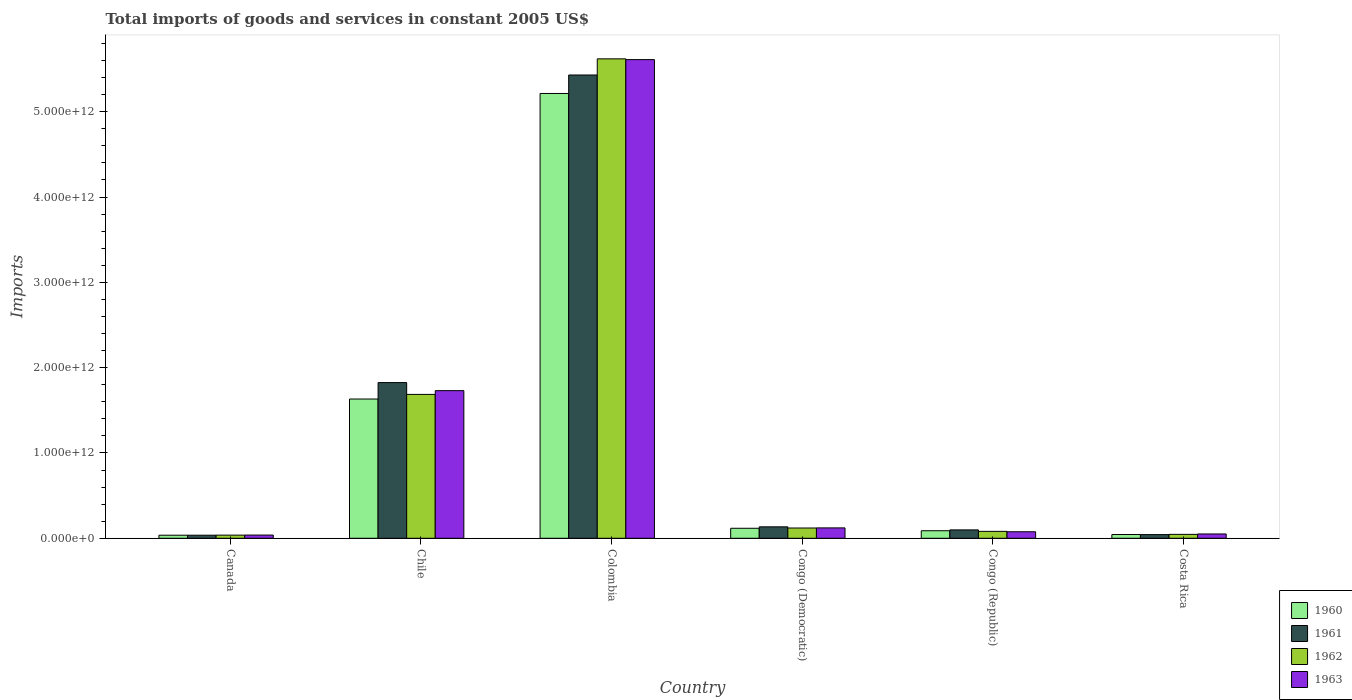Are the number of bars per tick equal to the number of legend labels?
Keep it short and to the point. Yes. How many bars are there on the 5th tick from the right?
Ensure brevity in your answer.  4. What is the label of the 4th group of bars from the left?
Your response must be concise. Congo (Democratic). In how many cases, is the number of bars for a given country not equal to the number of legend labels?
Your answer should be compact. 0. What is the total imports of goods and services in 1960 in Congo (Democratic)?
Provide a short and direct response. 1.17e+11. Across all countries, what is the maximum total imports of goods and services in 1963?
Provide a short and direct response. 5.61e+12. Across all countries, what is the minimum total imports of goods and services in 1960?
Make the answer very short. 3.60e+1. In which country was the total imports of goods and services in 1963 minimum?
Provide a short and direct response. Canada. What is the total total imports of goods and services in 1960 in the graph?
Make the answer very short. 7.13e+12. What is the difference between the total imports of goods and services in 1963 in Canada and that in Chile?
Your answer should be compact. -1.69e+12. What is the difference between the total imports of goods and services in 1960 in Chile and the total imports of goods and services in 1963 in Costa Rica?
Ensure brevity in your answer.  1.58e+12. What is the average total imports of goods and services in 1961 per country?
Offer a very short reply. 1.26e+12. What is the difference between the total imports of goods and services of/in 1963 and total imports of goods and services of/in 1961 in Costa Rica?
Your response must be concise. 7.69e+09. What is the ratio of the total imports of goods and services in 1963 in Colombia to that in Congo (Republic)?
Your response must be concise. 73.33. What is the difference between the highest and the second highest total imports of goods and services in 1961?
Your answer should be compact. -3.61e+12. What is the difference between the highest and the lowest total imports of goods and services in 1962?
Keep it short and to the point. 5.58e+12. Is the sum of the total imports of goods and services in 1963 in Canada and Costa Rica greater than the maximum total imports of goods and services in 1961 across all countries?
Make the answer very short. No. Is it the case that in every country, the sum of the total imports of goods and services in 1960 and total imports of goods and services in 1962 is greater than the sum of total imports of goods and services in 1961 and total imports of goods and services in 1963?
Offer a terse response. No. What does the 1st bar from the right in Colombia represents?
Your answer should be very brief. 1963. Is it the case that in every country, the sum of the total imports of goods and services in 1963 and total imports of goods and services in 1961 is greater than the total imports of goods and services in 1962?
Give a very brief answer. Yes. Are all the bars in the graph horizontal?
Your response must be concise. No. What is the difference between two consecutive major ticks on the Y-axis?
Your answer should be very brief. 1.00e+12. Are the values on the major ticks of Y-axis written in scientific E-notation?
Provide a short and direct response. Yes. Does the graph contain any zero values?
Provide a short and direct response. No. Where does the legend appear in the graph?
Give a very brief answer. Bottom right. What is the title of the graph?
Ensure brevity in your answer.  Total imports of goods and services in constant 2005 US$. Does "2007" appear as one of the legend labels in the graph?
Your response must be concise. No. What is the label or title of the Y-axis?
Your response must be concise. Imports. What is the Imports of 1960 in Canada?
Provide a succinct answer. 3.60e+1. What is the Imports in 1961 in Canada?
Offer a terse response. 3.61e+1. What is the Imports in 1962 in Canada?
Give a very brief answer. 3.69e+1. What is the Imports of 1963 in Canada?
Your response must be concise. 3.79e+1. What is the Imports in 1960 in Chile?
Make the answer very short. 1.63e+12. What is the Imports in 1961 in Chile?
Your answer should be very brief. 1.82e+12. What is the Imports of 1962 in Chile?
Your response must be concise. 1.69e+12. What is the Imports of 1963 in Chile?
Offer a terse response. 1.73e+12. What is the Imports of 1960 in Colombia?
Your answer should be compact. 5.21e+12. What is the Imports of 1961 in Colombia?
Give a very brief answer. 5.43e+12. What is the Imports in 1962 in Colombia?
Your answer should be very brief. 5.62e+12. What is the Imports in 1963 in Colombia?
Offer a very short reply. 5.61e+12. What is the Imports of 1960 in Congo (Democratic)?
Give a very brief answer. 1.17e+11. What is the Imports of 1961 in Congo (Democratic)?
Ensure brevity in your answer.  1.34e+11. What is the Imports of 1962 in Congo (Democratic)?
Your response must be concise. 1.20e+11. What is the Imports in 1963 in Congo (Democratic)?
Ensure brevity in your answer.  1.22e+11. What is the Imports of 1960 in Congo (Republic)?
Your answer should be compact. 8.83e+1. What is the Imports in 1961 in Congo (Republic)?
Ensure brevity in your answer.  9.83e+1. What is the Imports in 1962 in Congo (Republic)?
Your response must be concise. 8.10e+1. What is the Imports in 1963 in Congo (Republic)?
Ensure brevity in your answer.  7.65e+1. What is the Imports of 1960 in Costa Rica?
Ensure brevity in your answer.  4.40e+1. What is the Imports of 1961 in Costa Rica?
Your response must be concise. 4.30e+1. What is the Imports of 1962 in Costa Rica?
Your answer should be compact. 4.58e+1. What is the Imports of 1963 in Costa Rica?
Your response must be concise. 5.07e+1. Across all countries, what is the maximum Imports in 1960?
Your response must be concise. 5.21e+12. Across all countries, what is the maximum Imports of 1961?
Make the answer very short. 5.43e+12. Across all countries, what is the maximum Imports of 1962?
Offer a very short reply. 5.62e+12. Across all countries, what is the maximum Imports of 1963?
Your response must be concise. 5.61e+12. Across all countries, what is the minimum Imports in 1960?
Keep it short and to the point. 3.60e+1. Across all countries, what is the minimum Imports of 1961?
Your response must be concise. 3.61e+1. Across all countries, what is the minimum Imports in 1962?
Your response must be concise. 3.69e+1. Across all countries, what is the minimum Imports in 1963?
Offer a terse response. 3.79e+1. What is the total Imports in 1960 in the graph?
Your answer should be very brief. 7.13e+12. What is the total Imports of 1961 in the graph?
Provide a succinct answer. 7.57e+12. What is the total Imports in 1962 in the graph?
Ensure brevity in your answer.  7.59e+12. What is the total Imports of 1963 in the graph?
Provide a succinct answer. 7.63e+12. What is the difference between the Imports in 1960 in Canada and that in Chile?
Keep it short and to the point. -1.60e+12. What is the difference between the Imports of 1961 in Canada and that in Chile?
Your answer should be very brief. -1.79e+12. What is the difference between the Imports in 1962 in Canada and that in Chile?
Ensure brevity in your answer.  -1.65e+12. What is the difference between the Imports in 1963 in Canada and that in Chile?
Offer a very short reply. -1.69e+12. What is the difference between the Imports of 1960 in Canada and that in Colombia?
Provide a short and direct response. -5.18e+12. What is the difference between the Imports in 1961 in Canada and that in Colombia?
Your answer should be compact. -5.39e+12. What is the difference between the Imports of 1962 in Canada and that in Colombia?
Your response must be concise. -5.58e+12. What is the difference between the Imports of 1963 in Canada and that in Colombia?
Ensure brevity in your answer.  -5.57e+12. What is the difference between the Imports in 1960 in Canada and that in Congo (Democratic)?
Give a very brief answer. -8.14e+1. What is the difference between the Imports of 1961 in Canada and that in Congo (Democratic)?
Your response must be concise. -9.81e+1. What is the difference between the Imports in 1962 in Canada and that in Congo (Democratic)?
Provide a short and direct response. -8.36e+1. What is the difference between the Imports of 1963 in Canada and that in Congo (Democratic)?
Provide a succinct answer. -8.39e+1. What is the difference between the Imports of 1960 in Canada and that in Congo (Republic)?
Your answer should be very brief. -5.24e+1. What is the difference between the Imports of 1961 in Canada and that in Congo (Republic)?
Make the answer very short. -6.22e+1. What is the difference between the Imports of 1962 in Canada and that in Congo (Republic)?
Your answer should be compact. -4.41e+1. What is the difference between the Imports in 1963 in Canada and that in Congo (Republic)?
Your answer should be compact. -3.86e+1. What is the difference between the Imports in 1960 in Canada and that in Costa Rica?
Offer a very short reply. -8.03e+09. What is the difference between the Imports in 1961 in Canada and that in Costa Rica?
Your answer should be very brief. -6.97e+09. What is the difference between the Imports of 1962 in Canada and that in Costa Rica?
Keep it short and to the point. -8.88e+09. What is the difference between the Imports in 1963 in Canada and that in Costa Rica?
Your answer should be compact. -1.28e+1. What is the difference between the Imports in 1960 in Chile and that in Colombia?
Provide a short and direct response. -3.58e+12. What is the difference between the Imports in 1961 in Chile and that in Colombia?
Your answer should be compact. -3.61e+12. What is the difference between the Imports of 1962 in Chile and that in Colombia?
Your response must be concise. -3.93e+12. What is the difference between the Imports of 1963 in Chile and that in Colombia?
Keep it short and to the point. -3.88e+12. What is the difference between the Imports in 1960 in Chile and that in Congo (Democratic)?
Give a very brief answer. 1.51e+12. What is the difference between the Imports of 1961 in Chile and that in Congo (Democratic)?
Provide a succinct answer. 1.69e+12. What is the difference between the Imports in 1962 in Chile and that in Congo (Democratic)?
Ensure brevity in your answer.  1.57e+12. What is the difference between the Imports in 1963 in Chile and that in Congo (Democratic)?
Ensure brevity in your answer.  1.61e+12. What is the difference between the Imports in 1960 in Chile and that in Congo (Republic)?
Your answer should be compact. 1.54e+12. What is the difference between the Imports in 1961 in Chile and that in Congo (Republic)?
Provide a short and direct response. 1.73e+12. What is the difference between the Imports of 1962 in Chile and that in Congo (Republic)?
Offer a terse response. 1.61e+12. What is the difference between the Imports in 1963 in Chile and that in Congo (Republic)?
Make the answer very short. 1.65e+12. What is the difference between the Imports in 1960 in Chile and that in Costa Rica?
Provide a short and direct response. 1.59e+12. What is the difference between the Imports of 1961 in Chile and that in Costa Rica?
Your answer should be very brief. 1.78e+12. What is the difference between the Imports of 1962 in Chile and that in Costa Rica?
Offer a very short reply. 1.64e+12. What is the difference between the Imports of 1963 in Chile and that in Costa Rica?
Ensure brevity in your answer.  1.68e+12. What is the difference between the Imports of 1960 in Colombia and that in Congo (Democratic)?
Provide a short and direct response. 5.10e+12. What is the difference between the Imports in 1961 in Colombia and that in Congo (Democratic)?
Provide a short and direct response. 5.30e+12. What is the difference between the Imports in 1962 in Colombia and that in Congo (Democratic)?
Provide a succinct answer. 5.50e+12. What is the difference between the Imports of 1963 in Colombia and that in Congo (Democratic)?
Provide a succinct answer. 5.49e+12. What is the difference between the Imports in 1960 in Colombia and that in Congo (Republic)?
Offer a terse response. 5.13e+12. What is the difference between the Imports of 1961 in Colombia and that in Congo (Republic)?
Provide a succinct answer. 5.33e+12. What is the difference between the Imports in 1962 in Colombia and that in Congo (Republic)?
Offer a terse response. 5.54e+12. What is the difference between the Imports of 1963 in Colombia and that in Congo (Republic)?
Give a very brief answer. 5.53e+12. What is the difference between the Imports of 1960 in Colombia and that in Costa Rica?
Give a very brief answer. 5.17e+12. What is the difference between the Imports of 1961 in Colombia and that in Costa Rica?
Ensure brevity in your answer.  5.39e+12. What is the difference between the Imports in 1962 in Colombia and that in Costa Rica?
Provide a succinct answer. 5.57e+12. What is the difference between the Imports of 1963 in Colombia and that in Costa Rica?
Give a very brief answer. 5.56e+12. What is the difference between the Imports of 1960 in Congo (Democratic) and that in Congo (Republic)?
Give a very brief answer. 2.90e+1. What is the difference between the Imports in 1961 in Congo (Democratic) and that in Congo (Republic)?
Offer a terse response. 3.59e+1. What is the difference between the Imports in 1962 in Congo (Democratic) and that in Congo (Republic)?
Provide a short and direct response. 3.95e+1. What is the difference between the Imports in 1963 in Congo (Democratic) and that in Congo (Republic)?
Your answer should be very brief. 4.53e+1. What is the difference between the Imports of 1960 in Congo (Democratic) and that in Costa Rica?
Your response must be concise. 7.34e+1. What is the difference between the Imports in 1961 in Congo (Democratic) and that in Costa Rica?
Provide a succinct answer. 9.11e+1. What is the difference between the Imports in 1962 in Congo (Democratic) and that in Costa Rica?
Your response must be concise. 7.47e+1. What is the difference between the Imports of 1963 in Congo (Democratic) and that in Costa Rica?
Provide a short and direct response. 7.11e+1. What is the difference between the Imports in 1960 in Congo (Republic) and that in Costa Rica?
Provide a succinct answer. 4.43e+1. What is the difference between the Imports of 1961 in Congo (Republic) and that in Costa Rica?
Your answer should be compact. 5.52e+1. What is the difference between the Imports of 1962 in Congo (Republic) and that in Costa Rica?
Keep it short and to the point. 3.52e+1. What is the difference between the Imports of 1963 in Congo (Republic) and that in Costa Rica?
Keep it short and to the point. 2.58e+1. What is the difference between the Imports in 1960 in Canada and the Imports in 1961 in Chile?
Offer a very short reply. -1.79e+12. What is the difference between the Imports in 1960 in Canada and the Imports in 1962 in Chile?
Offer a very short reply. -1.65e+12. What is the difference between the Imports of 1960 in Canada and the Imports of 1963 in Chile?
Your answer should be compact. -1.69e+12. What is the difference between the Imports in 1961 in Canada and the Imports in 1962 in Chile?
Provide a short and direct response. -1.65e+12. What is the difference between the Imports in 1961 in Canada and the Imports in 1963 in Chile?
Ensure brevity in your answer.  -1.69e+12. What is the difference between the Imports in 1962 in Canada and the Imports in 1963 in Chile?
Your response must be concise. -1.69e+12. What is the difference between the Imports in 1960 in Canada and the Imports in 1961 in Colombia?
Ensure brevity in your answer.  -5.39e+12. What is the difference between the Imports in 1960 in Canada and the Imports in 1962 in Colombia?
Provide a short and direct response. -5.58e+12. What is the difference between the Imports of 1960 in Canada and the Imports of 1963 in Colombia?
Provide a succinct answer. -5.57e+12. What is the difference between the Imports of 1961 in Canada and the Imports of 1962 in Colombia?
Make the answer very short. -5.58e+12. What is the difference between the Imports of 1961 in Canada and the Imports of 1963 in Colombia?
Ensure brevity in your answer.  -5.57e+12. What is the difference between the Imports of 1962 in Canada and the Imports of 1963 in Colombia?
Ensure brevity in your answer.  -5.57e+12. What is the difference between the Imports of 1960 in Canada and the Imports of 1961 in Congo (Democratic)?
Your answer should be very brief. -9.82e+1. What is the difference between the Imports in 1960 in Canada and the Imports in 1962 in Congo (Democratic)?
Your answer should be compact. -8.45e+1. What is the difference between the Imports of 1960 in Canada and the Imports of 1963 in Congo (Democratic)?
Keep it short and to the point. -8.58e+1. What is the difference between the Imports of 1961 in Canada and the Imports of 1962 in Congo (Democratic)?
Keep it short and to the point. -8.44e+1. What is the difference between the Imports in 1961 in Canada and the Imports in 1963 in Congo (Democratic)?
Provide a short and direct response. -8.57e+1. What is the difference between the Imports of 1962 in Canada and the Imports of 1963 in Congo (Democratic)?
Give a very brief answer. -8.49e+1. What is the difference between the Imports of 1960 in Canada and the Imports of 1961 in Congo (Republic)?
Ensure brevity in your answer.  -6.23e+1. What is the difference between the Imports in 1960 in Canada and the Imports in 1962 in Congo (Republic)?
Offer a terse response. -4.50e+1. What is the difference between the Imports of 1960 in Canada and the Imports of 1963 in Congo (Republic)?
Offer a very short reply. -4.05e+1. What is the difference between the Imports of 1961 in Canada and the Imports of 1962 in Congo (Republic)?
Ensure brevity in your answer.  -4.49e+1. What is the difference between the Imports in 1961 in Canada and the Imports in 1963 in Congo (Republic)?
Your response must be concise. -4.04e+1. What is the difference between the Imports in 1962 in Canada and the Imports in 1963 in Congo (Republic)?
Keep it short and to the point. -3.96e+1. What is the difference between the Imports of 1960 in Canada and the Imports of 1961 in Costa Rica?
Provide a short and direct response. -7.06e+09. What is the difference between the Imports in 1960 in Canada and the Imports in 1962 in Costa Rica?
Your response must be concise. -9.81e+09. What is the difference between the Imports of 1960 in Canada and the Imports of 1963 in Costa Rica?
Ensure brevity in your answer.  -1.47e+1. What is the difference between the Imports of 1961 in Canada and the Imports of 1962 in Costa Rica?
Provide a succinct answer. -9.72e+09. What is the difference between the Imports of 1961 in Canada and the Imports of 1963 in Costa Rica?
Make the answer very short. -1.47e+1. What is the difference between the Imports of 1962 in Canada and the Imports of 1963 in Costa Rica?
Your answer should be very brief. -1.38e+1. What is the difference between the Imports of 1960 in Chile and the Imports of 1961 in Colombia?
Your answer should be compact. -3.80e+12. What is the difference between the Imports of 1960 in Chile and the Imports of 1962 in Colombia?
Your answer should be compact. -3.99e+12. What is the difference between the Imports of 1960 in Chile and the Imports of 1963 in Colombia?
Ensure brevity in your answer.  -3.98e+12. What is the difference between the Imports in 1961 in Chile and the Imports in 1962 in Colombia?
Provide a short and direct response. -3.79e+12. What is the difference between the Imports in 1961 in Chile and the Imports in 1963 in Colombia?
Offer a terse response. -3.79e+12. What is the difference between the Imports of 1962 in Chile and the Imports of 1963 in Colombia?
Give a very brief answer. -3.92e+12. What is the difference between the Imports of 1960 in Chile and the Imports of 1961 in Congo (Democratic)?
Your response must be concise. 1.50e+12. What is the difference between the Imports in 1960 in Chile and the Imports in 1962 in Congo (Democratic)?
Give a very brief answer. 1.51e+12. What is the difference between the Imports in 1960 in Chile and the Imports in 1963 in Congo (Democratic)?
Your answer should be compact. 1.51e+12. What is the difference between the Imports in 1961 in Chile and the Imports in 1962 in Congo (Democratic)?
Offer a terse response. 1.70e+12. What is the difference between the Imports in 1961 in Chile and the Imports in 1963 in Congo (Democratic)?
Keep it short and to the point. 1.70e+12. What is the difference between the Imports in 1962 in Chile and the Imports in 1963 in Congo (Democratic)?
Your answer should be very brief. 1.56e+12. What is the difference between the Imports of 1960 in Chile and the Imports of 1961 in Congo (Republic)?
Your answer should be very brief. 1.53e+12. What is the difference between the Imports of 1960 in Chile and the Imports of 1962 in Congo (Republic)?
Keep it short and to the point. 1.55e+12. What is the difference between the Imports of 1960 in Chile and the Imports of 1963 in Congo (Republic)?
Your answer should be very brief. 1.56e+12. What is the difference between the Imports in 1961 in Chile and the Imports in 1962 in Congo (Republic)?
Your answer should be very brief. 1.74e+12. What is the difference between the Imports in 1961 in Chile and the Imports in 1963 in Congo (Republic)?
Keep it short and to the point. 1.75e+12. What is the difference between the Imports of 1962 in Chile and the Imports of 1963 in Congo (Republic)?
Your answer should be very brief. 1.61e+12. What is the difference between the Imports of 1960 in Chile and the Imports of 1961 in Costa Rica?
Your answer should be very brief. 1.59e+12. What is the difference between the Imports of 1960 in Chile and the Imports of 1962 in Costa Rica?
Offer a terse response. 1.59e+12. What is the difference between the Imports in 1960 in Chile and the Imports in 1963 in Costa Rica?
Your answer should be very brief. 1.58e+12. What is the difference between the Imports of 1961 in Chile and the Imports of 1962 in Costa Rica?
Give a very brief answer. 1.78e+12. What is the difference between the Imports in 1961 in Chile and the Imports in 1963 in Costa Rica?
Your response must be concise. 1.77e+12. What is the difference between the Imports in 1962 in Chile and the Imports in 1963 in Costa Rica?
Your answer should be compact. 1.64e+12. What is the difference between the Imports of 1960 in Colombia and the Imports of 1961 in Congo (Democratic)?
Your answer should be very brief. 5.08e+12. What is the difference between the Imports in 1960 in Colombia and the Imports in 1962 in Congo (Democratic)?
Give a very brief answer. 5.09e+12. What is the difference between the Imports in 1960 in Colombia and the Imports in 1963 in Congo (Democratic)?
Make the answer very short. 5.09e+12. What is the difference between the Imports in 1961 in Colombia and the Imports in 1962 in Congo (Democratic)?
Offer a very short reply. 5.31e+12. What is the difference between the Imports in 1961 in Colombia and the Imports in 1963 in Congo (Democratic)?
Offer a terse response. 5.31e+12. What is the difference between the Imports of 1962 in Colombia and the Imports of 1963 in Congo (Democratic)?
Your response must be concise. 5.50e+12. What is the difference between the Imports of 1960 in Colombia and the Imports of 1961 in Congo (Republic)?
Your answer should be very brief. 5.12e+12. What is the difference between the Imports in 1960 in Colombia and the Imports in 1962 in Congo (Republic)?
Your answer should be very brief. 5.13e+12. What is the difference between the Imports of 1960 in Colombia and the Imports of 1963 in Congo (Republic)?
Offer a very short reply. 5.14e+12. What is the difference between the Imports in 1961 in Colombia and the Imports in 1962 in Congo (Republic)?
Your response must be concise. 5.35e+12. What is the difference between the Imports of 1961 in Colombia and the Imports of 1963 in Congo (Republic)?
Your answer should be compact. 5.35e+12. What is the difference between the Imports of 1962 in Colombia and the Imports of 1963 in Congo (Republic)?
Make the answer very short. 5.54e+12. What is the difference between the Imports of 1960 in Colombia and the Imports of 1961 in Costa Rica?
Your answer should be very brief. 5.17e+12. What is the difference between the Imports of 1960 in Colombia and the Imports of 1962 in Costa Rica?
Your answer should be very brief. 5.17e+12. What is the difference between the Imports of 1960 in Colombia and the Imports of 1963 in Costa Rica?
Offer a terse response. 5.16e+12. What is the difference between the Imports of 1961 in Colombia and the Imports of 1962 in Costa Rica?
Provide a succinct answer. 5.38e+12. What is the difference between the Imports of 1961 in Colombia and the Imports of 1963 in Costa Rica?
Give a very brief answer. 5.38e+12. What is the difference between the Imports in 1962 in Colombia and the Imports in 1963 in Costa Rica?
Give a very brief answer. 5.57e+12. What is the difference between the Imports of 1960 in Congo (Democratic) and the Imports of 1961 in Congo (Republic)?
Your answer should be very brief. 1.91e+1. What is the difference between the Imports of 1960 in Congo (Democratic) and the Imports of 1962 in Congo (Republic)?
Give a very brief answer. 3.64e+1. What is the difference between the Imports in 1960 in Congo (Democratic) and the Imports in 1963 in Congo (Republic)?
Provide a short and direct response. 4.09e+1. What is the difference between the Imports in 1961 in Congo (Democratic) and the Imports in 1962 in Congo (Republic)?
Make the answer very short. 5.32e+1. What is the difference between the Imports in 1961 in Congo (Democratic) and the Imports in 1963 in Congo (Republic)?
Make the answer very short. 5.77e+1. What is the difference between the Imports in 1962 in Congo (Democratic) and the Imports in 1963 in Congo (Republic)?
Give a very brief answer. 4.40e+1. What is the difference between the Imports in 1960 in Congo (Democratic) and the Imports in 1961 in Costa Rica?
Your answer should be compact. 7.43e+1. What is the difference between the Imports in 1960 in Congo (Democratic) and the Imports in 1962 in Costa Rica?
Make the answer very short. 7.16e+1. What is the difference between the Imports of 1960 in Congo (Democratic) and the Imports of 1963 in Costa Rica?
Your answer should be compact. 6.66e+1. What is the difference between the Imports in 1961 in Congo (Democratic) and the Imports in 1962 in Costa Rica?
Make the answer very short. 8.84e+1. What is the difference between the Imports of 1961 in Congo (Democratic) and the Imports of 1963 in Costa Rica?
Ensure brevity in your answer.  8.34e+1. What is the difference between the Imports of 1962 in Congo (Democratic) and the Imports of 1963 in Costa Rica?
Your response must be concise. 6.98e+1. What is the difference between the Imports in 1960 in Congo (Republic) and the Imports in 1961 in Costa Rica?
Provide a short and direct response. 4.53e+1. What is the difference between the Imports in 1960 in Congo (Republic) and the Imports in 1962 in Costa Rica?
Provide a succinct answer. 4.26e+1. What is the difference between the Imports of 1960 in Congo (Republic) and the Imports of 1963 in Costa Rica?
Give a very brief answer. 3.76e+1. What is the difference between the Imports in 1961 in Congo (Republic) and the Imports in 1962 in Costa Rica?
Provide a short and direct response. 5.25e+1. What is the difference between the Imports in 1961 in Congo (Republic) and the Imports in 1963 in Costa Rica?
Give a very brief answer. 4.76e+1. What is the difference between the Imports in 1962 in Congo (Republic) and the Imports in 1963 in Costa Rica?
Provide a short and direct response. 3.03e+1. What is the average Imports of 1960 per country?
Your answer should be very brief. 1.19e+12. What is the average Imports in 1961 per country?
Provide a short and direct response. 1.26e+12. What is the average Imports of 1962 per country?
Your answer should be very brief. 1.26e+12. What is the average Imports in 1963 per country?
Your response must be concise. 1.27e+12. What is the difference between the Imports in 1960 and Imports in 1961 in Canada?
Provide a succinct answer. -9.09e+07. What is the difference between the Imports of 1960 and Imports of 1962 in Canada?
Make the answer very short. -9.27e+08. What is the difference between the Imports of 1960 and Imports of 1963 in Canada?
Your answer should be very brief. -1.91e+09. What is the difference between the Imports of 1961 and Imports of 1962 in Canada?
Give a very brief answer. -8.37e+08. What is the difference between the Imports of 1961 and Imports of 1963 in Canada?
Ensure brevity in your answer.  -1.82e+09. What is the difference between the Imports of 1962 and Imports of 1963 in Canada?
Offer a terse response. -9.82e+08. What is the difference between the Imports in 1960 and Imports in 1961 in Chile?
Your answer should be very brief. -1.93e+11. What is the difference between the Imports in 1960 and Imports in 1962 in Chile?
Your answer should be very brief. -5.42e+1. What is the difference between the Imports in 1960 and Imports in 1963 in Chile?
Make the answer very short. -9.81e+1. What is the difference between the Imports of 1961 and Imports of 1962 in Chile?
Your response must be concise. 1.39e+11. What is the difference between the Imports of 1961 and Imports of 1963 in Chile?
Your answer should be very brief. 9.46e+1. What is the difference between the Imports of 1962 and Imports of 1963 in Chile?
Your answer should be very brief. -4.39e+1. What is the difference between the Imports in 1960 and Imports in 1961 in Colombia?
Keep it short and to the point. -2.17e+11. What is the difference between the Imports of 1960 and Imports of 1962 in Colombia?
Make the answer very short. -4.06e+11. What is the difference between the Imports in 1960 and Imports in 1963 in Colombia?
Keep it short and to the point. -3.97e+11. What is the difference between the Imports in 1961 and Imports in 1962 in Colombia?
Ensure brevity in your answer.  -1.89e+11. What is the difference between the Imports of 1961 and Imports of 1963 in Colombia?
Give a very brief answer. -1.80e+11. What is the difference between the Imports in 1962 and Imports in 1963 in Colombia?
Offer a terse response. 9.11e+09. What is the difference between the Imports in 1960 and Imports in 1961 in Congo (Democratic)?
Make the answer very short. -1.68e+1. What is the difference between the Imports of 1960 and Imports of 1962 in Congo (Democratic)?
Offer a terse response. -3.13e+09. What is the difference between the Imports of 1960 and Imports of 1963 in Congo (Democratic)?
Your answer should be compact. -4.41e+09. What is the difference between the Imports of 1961 and Imports of 1962 in Congo (Democratic)?
Provide a short and direct response. 1.37e+1. What is the difference between the Imports in 1961 and Imports in 1963 in Congo (Democratic)?
Offer a terse response. 1.24e+1. What is the difference between the Imports of 1962 and Imports of 1963 in Congo (Democratic)?
Your answer should be very brief. -1.28e+09. What is the difference between the Imports in 1960 and Imports in 1961 in Congo (Republic)?
Make the answer very short. -9.92e+09. What is the difference between the Imports in 1960 and Imports in 1962 in Congo (Republic)?
Provide a short and direct response. 7.36e+09. What is the difference between the Imports in 1960 and Imports in 1963 in Congo (Republic)?
Keep it short and to the point. 1.18e+1. What is the difference between the Imports in 1961 and Imports in 1962 in Congo (Republic)?
Your answer should be compact. 1.73e+1. What is the difference between the Imports in 1961 and Imports in 1963 in Congo (Republic)?
Your answer should be compact. 2.18e+1. What is the difference between the Imports of 1962 and Imports of 1963 in Congo (Republic)?
Your response must be concise. 4.48e+09. What is the difference between the Imports of 1960 and Imports of 1961 in Costa Rica?
Provide a short and direct response. 9.75e+08. What is the difference between the Imports in 1960 and Imports in 1962 in Costa Rica?
Provide a short and direct response. -1.77e+09. What is the difference between the Imports in 1960 and Imports in 1963 in Costa Rica?
Provide a short and direct response. -6.71e+09. What is the difference between the Imports of 1961 and Imports of 1962 in Costa Rica?
Provide a short and direct response. -2.75e+09. What is the difference between the Imports in 1961 and Imports in 1963 in Costa Rica?
Your response must be concise. -7.69e+09. What is the difference between the Imports of 1962 and Imports of 1963 in Costa Rica?
Offer a terse response. -4.94e+09. What is the ratio of the Imports in 1960 in Canada to that in Chile?
Provide a short and direct response. 0.02. What is the ratio of the Imports of 1961 in Canada to that in Chile?
Offer a very short reply. 0.02. What is the ratio of the Imports of 1962 in Canada to that in Chile?
Keep it short and to the point. 0.02. What is the ratio of the Imports in 1963 in Canada to that in Chile?
Offer a very short reply. 0.02. What is the ratio of the Imports of 1960 in Canada to that in Colombia?
Your answer should be compact. 0.01. What is the ratio of the Imports of 1961 in Canada to that in Colombia?
Provide a succinct answer. 0.01. What is the ratio of the Imports in 1962 in Canada to that in Colombia?
Your answer should be compact. 0.01. What is the ratio of the Imports in 1963 in Canada to that in Colombia?
Offer a terse response. 0.01. What is the ratio of the Imports of 1960 in Canada to that in Congo (Democratic)?
Your answer should be very brief. 0.31. What is the ratio of the Imports in 1961 in Canada to that in Congo (Democratic)?
Make the answer very short. 0.27. What is the ratio of the Imports in 1962 in Canada to that in Congo (Democratic)?
Your answer should be compact. 0.31. What is the ratio of the Imports in 1963 in Canada to that in Congo (Democratic)?
Ensure brevity in your answer.  0.31. What is the ratio of the Imports of 1960 in Canada to that in Congo (Republic)?
Make the answer very short. 0.41. What is the ratio of the Imports in 1961 in Canada to that in Congo (Republic)?
Ensure brevity in your answer.  0.37. What is the ratio of the Imports in 1962 in Canada to that in Congo (Republic)?
Offer a terse response. 0.46. What is the ratio of the Imports of 1963 in Canada to that in Congo (Republic)?
Ensure brevity in your answer.  0.5. What is the ratio of the Imports of 1960 in Canada to that in Costa Rica?
Provide a short and direct response. 0.82. What is the ratio of the Imports in 1961 in Canada to that in Costa Rica?
Provide a short and direct response. 0.84. What is the ratio of the Imports in 1962 in Canada to that in Costa Rica?
Ensure brevity in your answer.  0.81. What is the ratio of the Imports of 1963 in Canada to that in Costa Rica?
Offer a very short reply. 0.75. What is the ratio of the Imports of 1960 in Chile to that in Colombia?
Your answer should be very brief. 0.31. What is the ratio of the Imports of 1961 in Chile to that in Colombia?
Provide a short and direct response. 0.34. What is the ratio of the Imports in 1962 in Chile to that in Colombia?
Your answer should be compact. 0.3. What is the ratio of the Imports of 1963 in Chile to that in Colombia?
Keep it short and to the point. 0.31. What is the ratio of the Imports of 1960 in Chile to that in Congo (Democratic)?
Keep it short and to the point. 13.91. What is the ratio of the Imports of 1961 in Chile to that in Congo (Democratic)?
Provide a short and direct response. 13.6. What is the ratio of the Imports in 1962 in Chile to that in Congo (Democratic)?
Keep it short and to the point. 14. What is the ratio of the Imports in 1963 in Chile to that in Congo (Democratic)?
Your response must be concise. 14.21. What is the ratio of the Imports in 1960 in Chile to that in Congo (Republic)?
Provide a succinct answer. 18.47. What is the ratio of the Imports of 1961 in Chile to that in Congo (Republic)?
Your response must be concise. 18.57. What is the ratio of the Imports of 1962 in Chile to that in Congo (Republic)?
Ensure brevity in your answer.  20.82. What is the ratio of the Imports of 1963 in Chile to that in Congo (Republic)?
Offer a very short reply. 22.62. What is the ratio of the Imports of 1960 in Chile to that in Costa Rica?
Offer a terse response. 37.09. What is the ratio of the Imports of 1961 in Chile to that in Costa Rica?
Give a very brief answer. 42.41. What is the ratio of the Imports in 1962 in Chile to that in Costa Rica?
Your answer should be compact. 36.84. What is the ratio of the Imports in 1963 in Chile to that in Costa Rica?
Keep it short and to the point. 34.12. What is the ratio of the Imports in 1960 in Colombia to that in Congo (Democratic)?
Your answer should be very brief. 44.42. What is the ratio of the Imports in 1961 in Colombia to that in Congo (Democratic)?
Your answer should be very brief. 40.47. What is the ratio of the Imports in 1962 in Colombia to that in Congo (Democratic)?
Give a very brief answer. 46.63. What is the ratio of the Imports in 1963 in Colombia to that in Congo (Democratic)?
Provide a short and direct response. 46.07. What is the ratio of the Imports of 1960 in Colombia to that in Congo (Republic)?
Your answer should be compact. 59.01. What is the ratio of the Imports of 1961 in Colombia to that in Congo (Republic)?
Your answer should be very brief. 55.26. What is the ratio of the Imports in 1962 in Colombia to that in Congo (Republic)?
Provide a short and direct response. 69.39. What is the ratio of the Imports in 1963 in Colombia to that in Congo (Republic)?
Give a very brief answer. 73.33. What is the ratio of the Imports in 1960 in Colombia to that in Costa Rica?
Provide a short and direct response. 118.47. What is the ratio of the Imports of 1961 in Colombia to that in Costa Rica?
Give a very brief answer. 126.19. What is the ratio of the Imports of 1962 in Colombia to that in Costa Rica?
Your answer should be compact. 122.75. What is the ratio of the Imports in 1963 in Colombia to that in Costa Rica?
Offer a terse response. 110.62. What is the ratio of the Imports in 1960 in Congo (Democratic) to that in Congo (Republic)?
Give a very brief answer. 1.33. What is the ratio of the Imports in 1961 in Congo (Democratic) to that in Congo (Republic)?
Your answer should be very brief. 1.37. What is the ratio of the Imports of 1962 in Congo (Democratic) to that in Congo (Republic)?
Make the answer very short. 1.49. What is the ratio of the Imports of 1963 in Congo (Democratic) to that in Congo (Republic)?
Ensure brevity in your answer.  1.59. What is the ratio of the Imports in 1960 in Congo (Democratic) to that in Costa Rica?
Give a very brief answer. 2.67. What is the ratio of the Imports of 1961 in Congo (Democratic) to that in Costa Rica?
Keep it short and to the point. 3.12. What is the ratio of the Imports in 1962 in Congo (Democratic) to that in Costa Rica?
Offer a terse response. 2.63. What is the ratio of the Imports of 1963 in Congo (Democratic) to that in Costa Rica?
Offer a very short reply. 2.4. What is the ratio of the Imports of 1960 in Congo (Republic) to that in Costa Rica?
Provide a short and direct response. 2.01. What is the ratio of the Imports in 1961 in Congo (Republic) to that in Costa Rica?
Ensure brevity in your answer.  2.28. What is the ratio of the Imports of 1962 in Congo (Republic) to that in Costa Rica?
Keep it short and to the point. 1.77. What is the ratio of the Imports in 1963 in Congo (Republic) to that in Costa Rica?
Provide a succinct answer. 1.51. What is the difference between the highest and the second highest Imports in 1960?
Ensure brevity in your answer.  3.58e+12. What is the difference between the highest and the second highest Imports of 1961?
Provide a short and direct response. 3.61e+12. What is the difference between the highest and the second highest Imports in 1962?
Give a very brief answer. 3.93e+12. What is the difference between the highest and the second highest Imports of 1963?
Give a very brief answer. 3.88e+12. What is the difference between the highest and the lowest Imports in 1960?
Make the answer very short. 5.18e+12. What is the difference between the highest and the lowest Imports of 1961?
Your answer should be compact. 5.39e+12. What is the difference between the highest and the lowest Imports in 1962?
Provide a short and direct response. 5.58e+12. What is the difference between the highest and the lowest Imports in 1963?
Your response must be concise. 5.57e+12. 